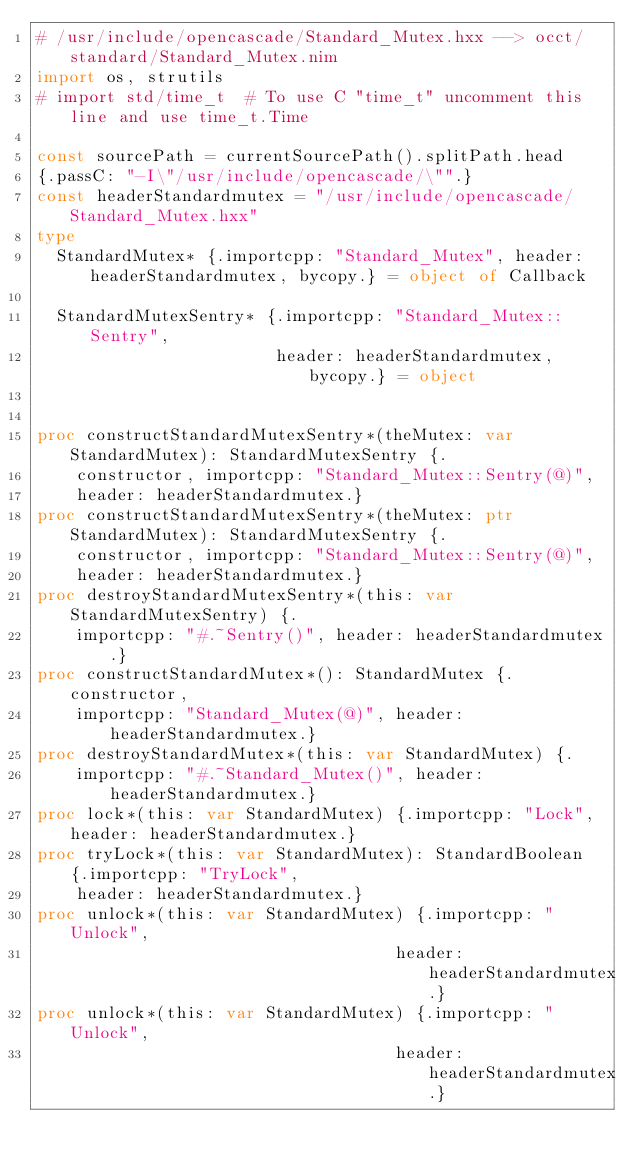<code> <loc_0><loc_0><loc_500><loc_500><_Nim_># /usr/include/opencascade/Standard_Mutex.hxx --> occt/standard/Standard_Mutex.nim
import os, strutils
# import std/time_t  # To use C "time_t" uncomment this line and use time_t.Time

const sourcePath = currentSourcePath().splitPath.head
{.passC: "-I\"/usr/include/opencascade/\"".}
const headerStandardmutex = "/usr/include/opencascade/Standard_Mutex.hxx"
type
  StandardMutex* {.importcpp: "Standard_Mutex", header: headerStandardmutex, bycopy.} = object of Callback

  StandardMutexSentry* {.importcpp: "Standard_Mutex::Sentry",
                        header: headerStandardmutex, bycopy.} = object


proc constructStandardMutexSentry*(theMutex: var StandardMutex): StandardMutexSentry {.
    constructor, importcpp: "Standard_Mutex::Sentry(@)",
    header: headerStandardmutex.}
proc constructStandardMutexSentry*(theMutex: ptr StandardMutex): StandardMutexSentry {.
    constructor, importcpp: "Standard_Mutex::Sentry(@)",
    header: headerStandardmutex.}
proc destroyStandardMutexSentry*(this: var StandardMutexSentry) {.
    importcpp: "#.~Sentry()", header: headerStandardmutex.}
proc constructStandardMutex*(): StandardMutex {.constructor,
    importcpp: "Standard_Mutex(@)", header: headerStandardmutex.}
proc destroyStandardMutex*(this: var StandardMutex) {.
    importcpp: "#.~Standard_Mutex()", header: headerStandardmutex.}
proc lock*(this: var StandardMutex) {.importcpp: "Lock", header: headerStandardmutex.}
proc tryLock*(this: var StandardMutex): StandardBoolean {.importcpp: "TryLock",
    header: headerStandardmutex.}
proc unlock*(this: var StandardMutex) {.importcpp: "Unlock",
                                    header: headerStandardmutex.}
proc unlock*(this: var StandardMutex) {.importcpp: "Unlock",
                                    header: headerStandardmutex.}</code> 